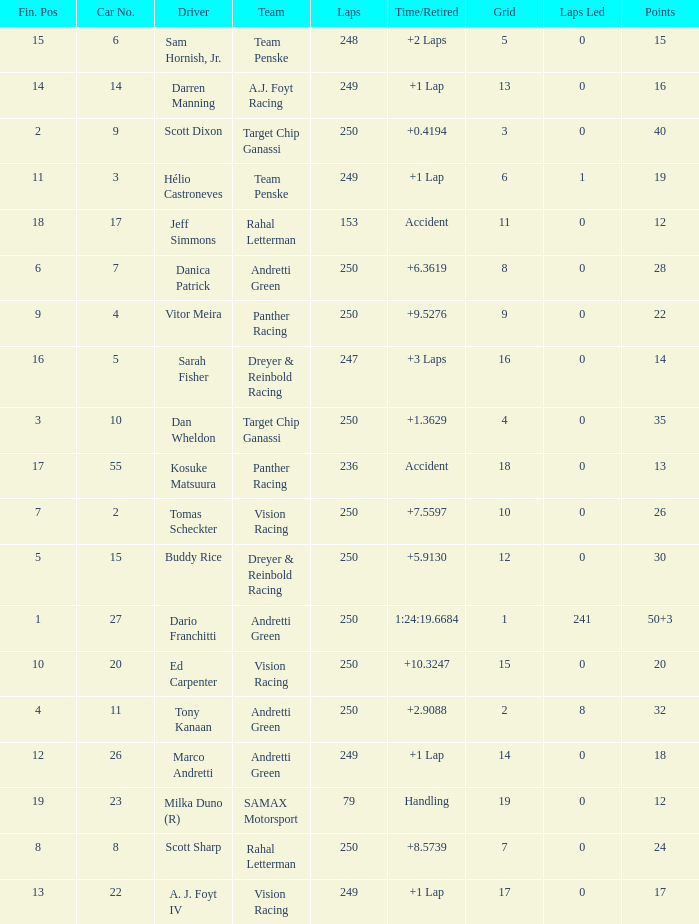Name the number of driver for fin pos of 19 1.0. 